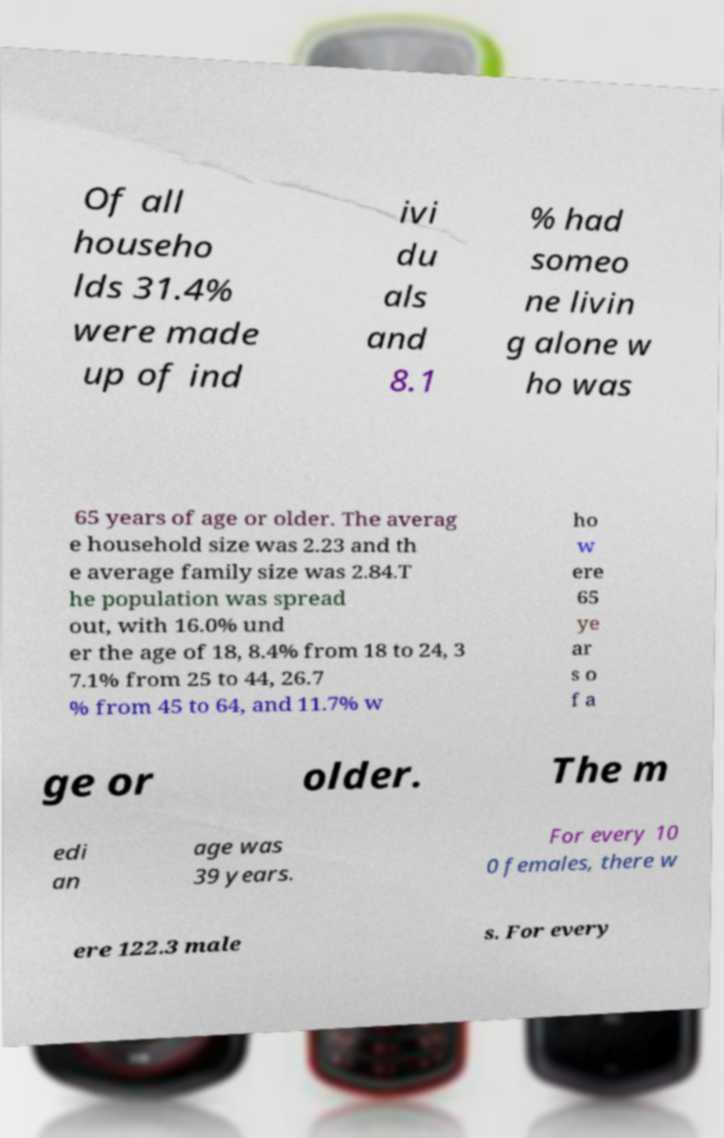Can you accurately transcribe the text from the provided image for me? Of all househo lds 31.4% were made up of ind ivi du als and 8.1 % had someo ne livin g alone w ho was 65 years of age or older. The averag e household size was 2.23 and th e average family size was 2.84.T he population was spread out, with 16.0% und er the age of 18, 8.4% from 18 to 24, 3 7.1% from 25 to 44, 26.7 % from 45 to 64, and 11.7% w ho w ere 65 ye ar s o f a ge or older. The m edi an age was 39 years. For every 10 0 females, there w ere 122.3 male s. For every 